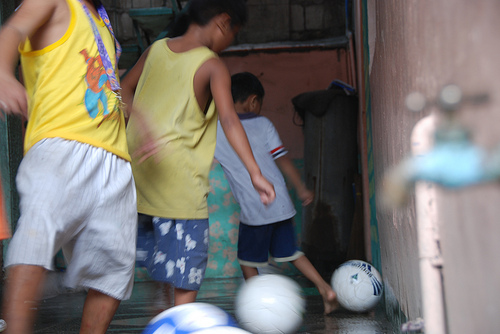<image>
Can you confirm if the ball is to the left of the boy? No. The ball is not to the left of the boy. From this viewpoint, they have a different horizontal relationship. 